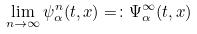<formula> <loc_0><loc_0><loc_500><loc_500>\lim _ { n \to \infty } \psi _ { \alpha } ^ { n } ( t , x ) = \colon \Psi ^ { \infty } _ { \alpha } ( t , x )</formula> 